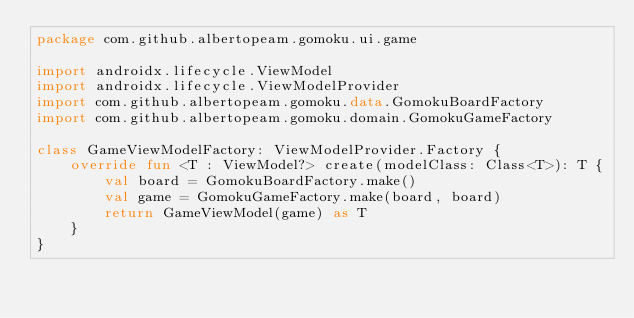<code> <loc_0><loc_0><loc_500><loc_500><_Kotlin_>package com.github.albertopeam.gomoku.ui.game

import androidx.lifecycle.ViewModel
import androidx.lifecycle.ViewModelProvider
import com.github.albertopeam.gomoku.data.GomokuBoardFactory
import com.github.albertopeam.gomoku.domain.GomokuGameFactory

class GameViewModelFactory: ViewModelProvider.Factory {
    override fun <T : ViewModel?> create(modelClass: Class<T>): T {
        val board = GomokuBoardFactory.make()
        val game = GomokuGameFactory.make(board, board)
        return GameViewModel(game) as T
    }
}</code> 